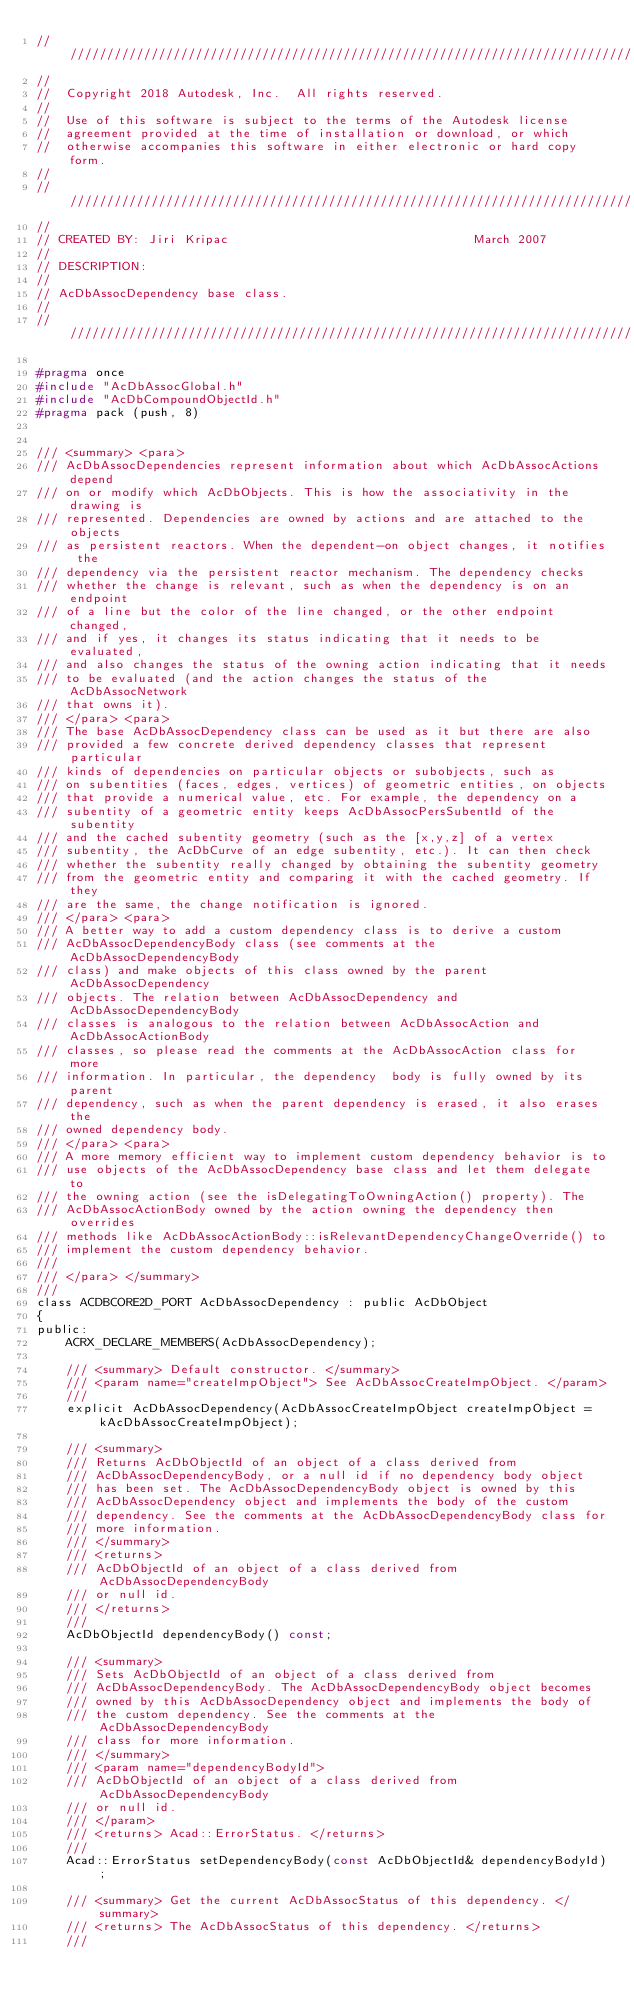<code> <loc_0><loc_0><loc_500><loc_500><_C_>//////////////////////////////////////////////////////////////////////////////
//
//  Copyright 2018 Autodesk, Inc.  All rights reserved.
//
//  Use of this software is subject to the terms of the Autodesk license 
//  agreement provided at the time of installation or download, or which 
//  otherwise accompanies this software in either electronic or hard copy form.   
//
//////////////////////////////////////////////////////////////////////////////
//
// CREATED BY: Jiri Kripac                                 March 2007
//
// DESCRIPTION:
//
// AcDbAssocDependency base class. 
//
//////////////////////////////////////////////////////////////////////////////

#pragma once
#include "AcDbAssocGlobal.h"
#include "AcDbCompoundObjectId.h"
#pragma pack (push, 8)


/// <summary> <para>
/// AcDbAssocDependencies represent information about which AcDbAssocActions depend 
/// on or modify which AcDbObjects. This is how the associativity in the drawing is 
/// represented. Dependencies are owned by actions and are attached to the objects 
/// as persistent reactors. When the dependent-on object changes, it notifies the
/// dependency via the persistent reactor mechanism. The dependency checks 
/// whether the change is relevant, such as when the dependency is on an endpoint 
/// of a line but the color of the line changed, or the other endpoint changed, 
/// and if yes, it changes its status indicating that it needs to be evaluated, 
/// and also changes the status of the owning action indicating that it needs 
/// to be evaluated (and the action changes the status of the AcDbAssocNetwork 
/// that owns it).
/// </para> <para>
/// The base AcDbAssocDependency class can be used as it but there are also
/// provided a few concrete derived dependency classes that represent particular 
/// kinds of dependencies on particular objects or subobjects, such as 
/// on subentities (faces, edges, vertices) of geometric entities, on objects
/// that provide a numerical value, etc. For example, the dependency on a 
/// subentity of a geometric entity keeps AcDbAssocPersSubentId of the subentity
/// and the cached subentity geometry (such as the [x,y,z] of a vertex 
/// subentity, the AcDbCurve of an edge subentity, etc.). It can then check 
/// whether the subentity really changed by obtaining the subentity geometry 
/// from the geometric entity and comparing it with the cached geometry. If they 
/// are the same, the change notification is ignored.
/// </para> <para>
/// A better way to add a custom dependency class is to derive a custom 
/// AcDbAssocDependencyBody class (see comments at the AcDbAssocDependencyBody 
/// class) and make objects of this class owned by the parent AcDbAssocDependency 
/// objects. The relation between AcDbAssocDependency and AcDbAssocDependencyBody 
/// classes is analogous to the relation between AcDbAssocAction and AcDbAssocActionBody 
/// classes, so please read the comments at the AcDbAssocAction class for more 
/// information. In particular, the dependency  body is fully owned by its parent 
/// dependency, such as when the parent dependency is erased, it also erases the 
/// owned dependency body. 
/// </para> <para>
/// A more memory efficient way to implement custom dependency behavior is to 
/// use objects of the AcDbAssocDependency base class and let them delegate to 
/// the owning action (see the isDelegatingToOwningAction() property). The
/// AcDbAssocActionBody owned by the action owning the dependency then overrides 
/// methods like AcDbAssocActionBody::isRelevantDependencyChangeOverride() to 
/// implement the custom dependency behavior.
/// 
/// </para> </summary>
///
class ACDBCORE2D_PORT AcDbAssocDependency : public AcDbObject
{
public: 
    ACRX_DECLARE_MEMBERS(AcDbAssocDependency);

    /// <summary> Default constructor. </summary>
    /// <param name="createImpObject"> See AcDbAssocCreateImpObject. </param>
    ///
    explicit AcDbAssocDependency(AcDbAssocCreateImpObject createImpObject = kAcDbAssocCreateImpObject);

    /// <summary> 
    /// Returns AcDbObjectId of an object of a class derived from 
    /// AcDbAssocDependencyBody, or a null id if no dependency body object
    /// has been set. The AcDbAssocDependencyBody object is owned by this 
    /// AcDbAssocDependency object and implements the body of the custom 
    /// dependency. See the comments at the AcDbAssocDependencyBody class for
    /// more information.
    /// </summary>
    /// <returns> 
    /// AcDbObjectId of an object of a class derived from AcDbAssocDependencyBody 
    /// or null id.
    /// </returns>
    ///
    AcDbObjectId dependencyBody() const;
    
    /// <summary> 
    /// Sets AcDbObjectId of an object of a class derived from 
    /// AcDbAssocDependencyBody. The AcDbAssocDependencyBody object becomes 
    /// owned by this AcDbAssocDependency object and implements the body of 
    /// the custom dependency. See the comments at the AcDbAssocDependencyBody 
    /// class for more information.
    /// </summary>
    /// <param name="dependencyBodyId"> 
    /// AcDbObjectId of an object of a class derived from AcDbAssocDependencyBody
    /// or null id. 
    /// </param>
    /// <returns> Acad::ErrorStatus. </returns>
    ///
    Acad::ErrorStatus setDependencyBody(const AcDbObjectId& dependencyBodyId);

    /// <summary> Get the current AcDbAssocStatus of this dependency. </summary>
    /// <returns> The AcDbAssocStatus of this dependency. </returns>
    ///</code> 